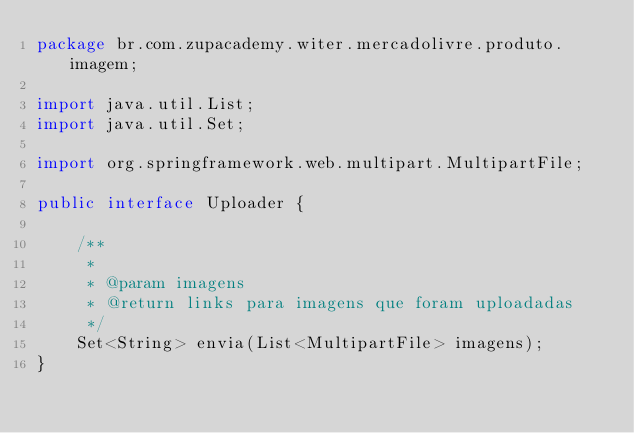<code> <loc_0><loc_0><loc_500><loc_500><_Java_>package br.com.zupacademy.witer.mercadolivre.produto.imagem;

import java.util.List;
import java.util.Set;

import org.springframework.web.multipart.MultipartFile;

public interface Uploader {

	/**
	 * 
	 * @param imagens
	 * @return links para imagens que foram uploadadas
	 */
	Set<String> envia(List<MultipartFile> imagens);
}
</code> 